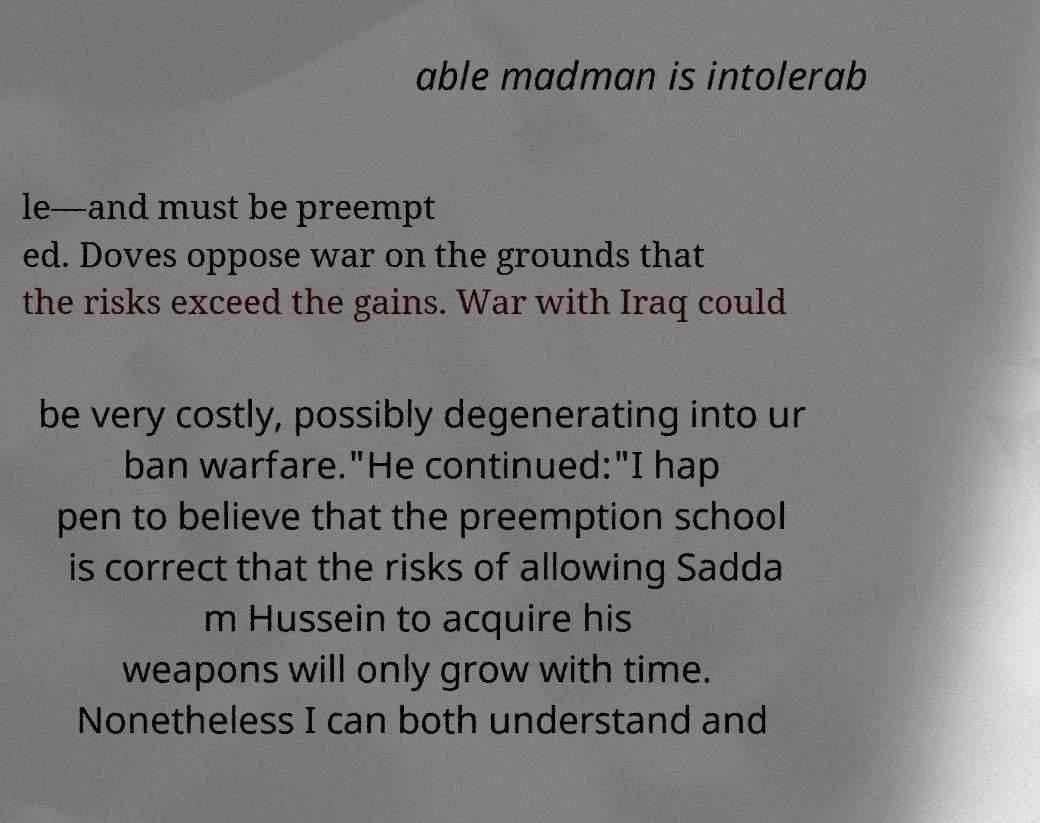Can you read and provide the text displayed in the image?This photo seems to have some interesting text. Can you extract and type it out for me? able madman is intolerab le—and must be preempt ed. Doves oppose war on the grounds that the risks exceed the gains. War with Iraq could be very costly, possibly degenerating into ur ban warfare."He continued:"I hap pen to believe that the preemption school is correct that the risks of allowing Sadda m Hussein to acquire his weapons will only grow with time. Nonetheless I can both understand and 